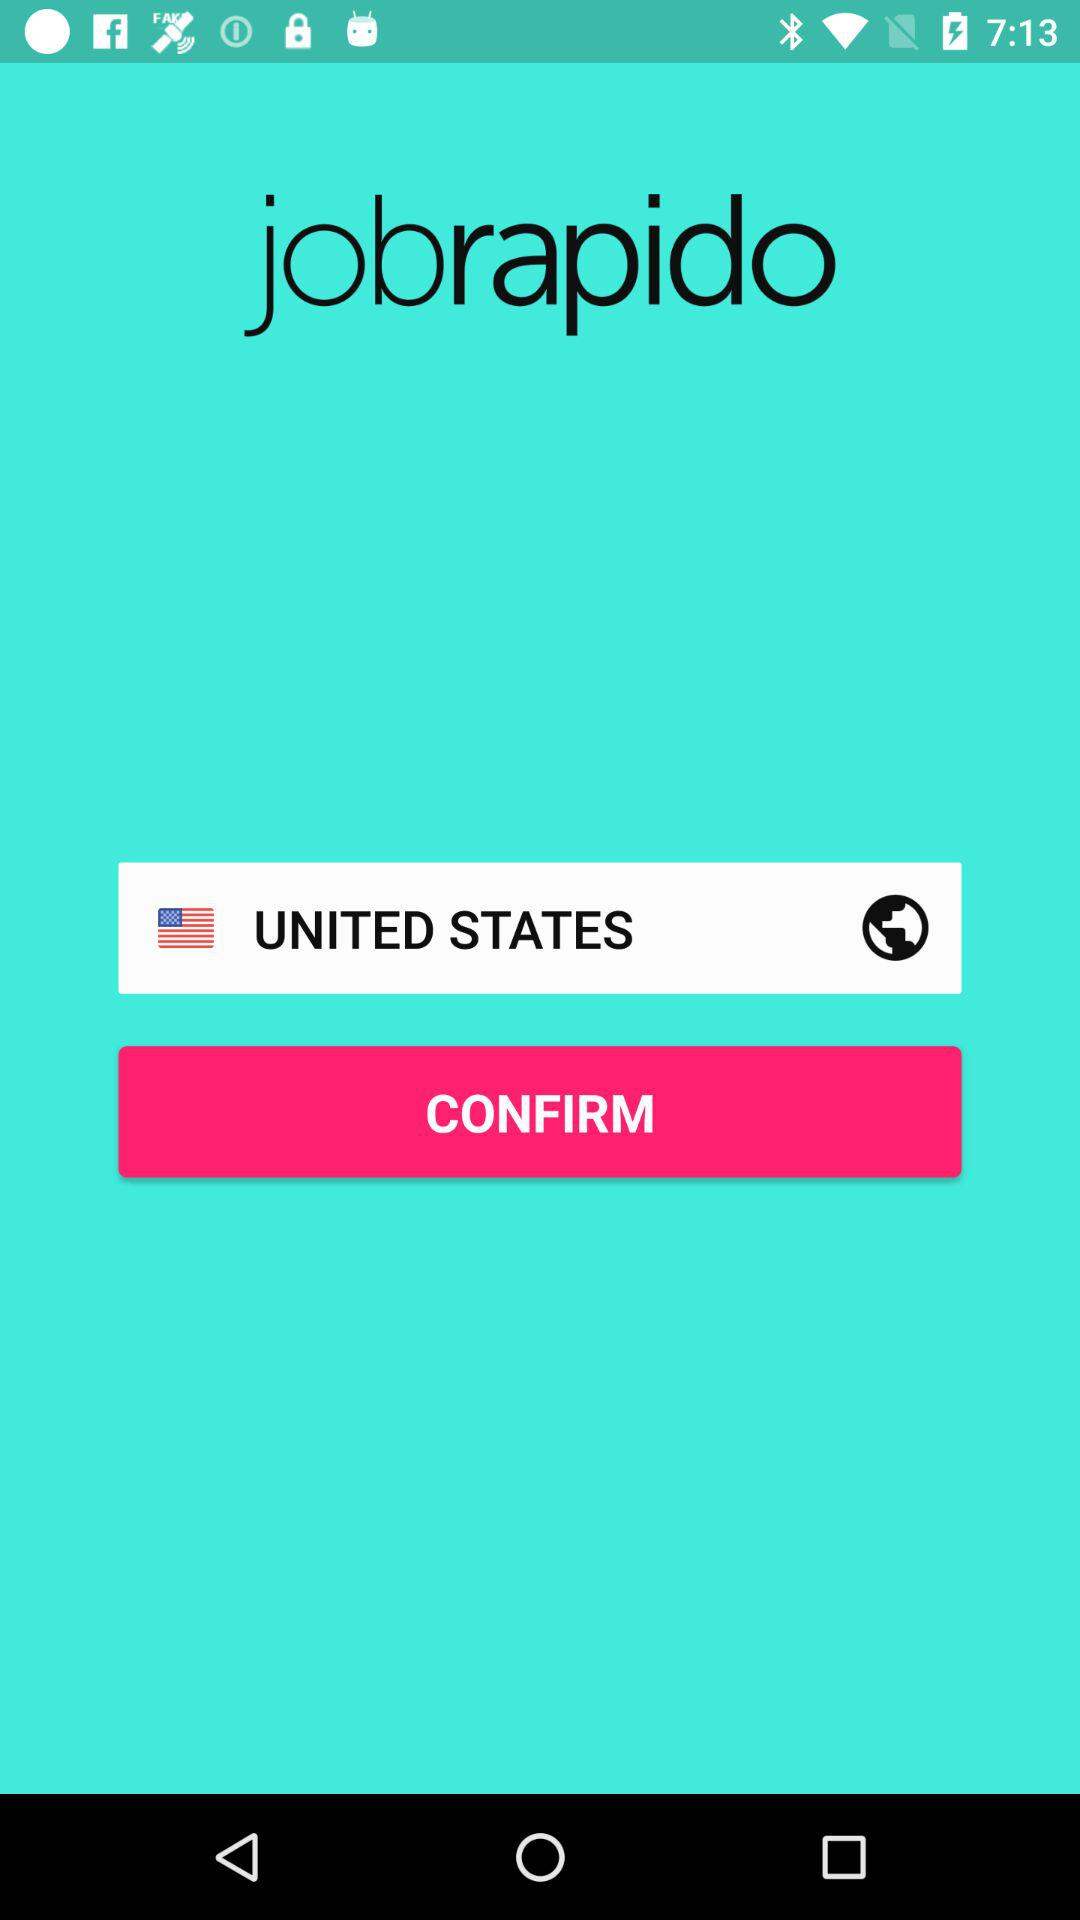What date is shown on the screen?
When the provided information is insufficient, respond with <no answer>. <no answer> 